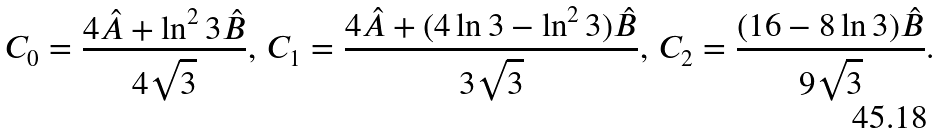Convert formula to latex. <formula><loc_0><loc_0><loc_500><loc_500>C _ { 0 } = \frac { 4 \hat { A } + \ln ^ { 2 } 3 \hat { B } } { 4 \sqrt { 3 } } , \, C _ { 1 } = \frac { 4 \hat { A } + ( 4 \ln 3 - \ln ^ { 2 } 3 ) \hat { B } } { 3 \sqrt { 3 } } , \, C _ { 2 } = \frac { ( 1 6 - 8 \ln 3 ) \hat { B } } { 9 \sqrt { 3 } } .</formula> 